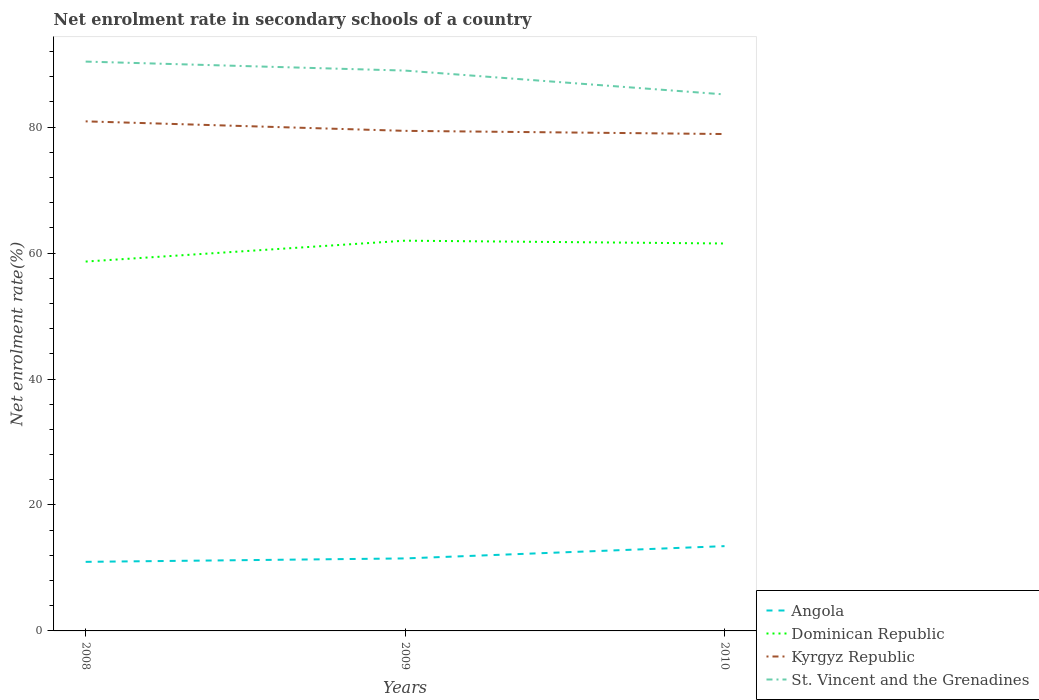How many different coloured lines are there?
Offer a terse response. 4. Does the line corresponding to Dominican Republic intersect with the line corresponding to Angola?
Your answer should be compact. No. Across all years, what is the maximum net enrolment rate in secondary schools in Angola?
Ensure brevity in your answer.  10.97. In which year was the net enrolment rate in secondary schools in Dominican Republic maximum?
Ensure brevity in your answer.  2008. What is the total net enrolment rate in secondary schools in Dominican Republic in the graph?
Your response must be concise. 0.45. What is the difference between the highest and the second highest net enrolment rate in secondary schools in St. Vincent and the Grenadines?
Ensure brevity in your answer.  5.21. What is the difference between the highest and the lowest net enrolment rate in secondary schools in Dominican Republic?
Your answer should be compact. 2. Is the net enrolment rate in secondary schools in Angola strictly greater than the net enrolment rate in secondary schools in St. Vincent and the Grenadines over the years?
Ensure brevity in your answer.  Yes. How many lines are there?
Your answer should be compact. 4. How many years are there in the graph?
Ensure brevity in your answer.  3. What is the difference between two consecutive major ticks on the Y-axis?
Offer a terse response. 20. Are the values on the major ticks of Y-axis written in scientific E-notation?
Your response must be concise. No. Does the graph contain any zero values?
Provide a succinct answer. No. Where does the legend appear in the graph?
Ensure brevity in your answer.  Bottom right. How many legend labels are there?
Provide a succinct answer. 4. How are the legend labels stacked?
Ensure brevity in your answer.  Vertical. What is the title of the graph?
Offer a terse response. Net enrolment rate in secondary schools of a country. What is the label or title of the Y-axis?
Provide a short and direct response. Net enrolment rate(%). What is the Net enrolment rate(%) in Angola in 2008?
Your response must be concise. 10.97. What is the Net enrolment rate(%) of Dominican Republic in 2008?
Offer a terse response. 58.66. What is the Net enrolment rate(%) in Kyrgyz Republic in 2008?
Keep it short and to the point. 80.92. What is the Net enrolment rate(%) of St. Vincent and the Grenadines in 2008?
Your answer should be very brief. 90.41. What is the Net enrolment rate(%) in Angola in 2009?
Your answer should be very brief. 11.51. What is the Net enrolment rate(%) in Dominican Republic in 2009?
Provide a succinct answer. 61.97. What is the Net enrolment rate(%) in Kyrgyz Republic in 2009?
Make the answer very short. 79.41. What is the Net enrolment rate(%) of St. Vincent and the Grenadines in 2009?
Your answer should be compact. 88.98. What is the Net enrolment rate(%) in Angola in 2010?
Offer a terse response. 13.46. What is the Net enrolment rate(%) in Dominican Republic in 2010?
Your response must be concise. 61.52. What is the Net enrolment rate(%) in Kyrgyz Republic in 2010?
Your response must be concise. 78.91. What is the Net enrolment rate(%) in St. Vincent and the Grenadines in 2010?
Your response must be concise. 85.2. Across all years, what is the maximum Net enrolment rate(%) of Angola?
Provide a short and direct response. 13.46. Across all years, what is the maximum Net enrolment rate(%) in Dominican Republic?
Give a very brief answer. 61.97. Across all years, what is the maximum Net enrolment rate(%) of Kyrgyz Republic?
Provide a succinct answer. 80.92. Across all years, what is the maximum Net enrolment rate(%) of St. Vincent and the Grenadines?
Your answer should be very brief. 90.41. Across all years, what is the minimum Net enrolment rate(%) in Angola?
Your answer should be very brief. 10.97. Across all years, what is the minimum Net enrolment rate(%) of Dominican Republic?
Keep it short and to the point. 58.66. Across all years, what is the minimum Net enrolment rate(%) in Kyrgyz Republic?
Make the answer very short. 78.91. Across all years, what is the minimum Net enrolment rate(%) of St. Vincent and the Grenadines?
Ensure brevity in your answer.  85.2. What is the total Net enrolment rate(%) in Angola in the graph?
Your answer should be very brief. 35.95. What is the total Net enrolment rate(%) in Dominican Republic in the graph?
Give a very brief answer. 182.15. What is the total Net enrolment rate(%) in Kyrgyz Republic in the graph?
Your answer should be compact. 239.24. What is the total Net enrolment rate(%) of St. Vincent and the Grenadines in the graph?
Offer a terse response. 264.59. What is the difference between the Net enrolment rate(%) in Angola in 2008 and that in 2009?
Make the answer very short. -0.54. What is the difference between the Net enrolment rate(%) in Dominican Republic in 2008 and that in 2009?
Offer a very short reply. -3.32. What is the difference between the Net enrolment rate(%) in Kyrgyz Republic in 2008 and that in 2009?
Provide a short and direct response. 1.51. What is the difference between the Net enrolment rate(%) in St. Vincent and the Grenadines in 2008 and that in 2009?
Your answer should be compact. 1.43. What is the difference between the Net enrolment rate(%) of Angola in 2008 and that in 2010?
Make the answer very short. -2.49. What is the difference between the Net enrolment rate(%) of Dominican Republic in 2008 and that in 2010?
Provide a short and direct response. -2.87. What is the difference between the Net enrolment rate(%) in Kyrgyz Republic in 2008 and that in 2010?
Make the answer very short. 2.01. What is the difference between the Net enrolment rate(%) of St. Vincent and the Grenadines in 2008 and that in 2010?
Your response must be concise. 5.21. What is the difference between the Net enrolment rate(%) of Angola in 2009 and that in 2010?
Give a very brief answer. -1.95. What is the difference between the Net enrolment rate(%) of Dominican Republic in 2009 and that in 2010?
Your answer should be very brief. 0.45. What is the difference between the Net enrolment rate(%) in Kyrgyz Republic in 2009 and that in 2010?
Your answer should be compact. 0.51. What is the difference between the Net enrolment rate(%) in St. Vincent and the Grenadines in 2009 and that in 2010?
Ensure brevity in your answer.  3.79. What is the difference between the Net enrolment rate(%) of Angola in 2008 and the Net enrolment rate(%) of Dominican Republic in 2009?
Offer a very short reply. -51. What is the difference between the Net enrolment rate(%) in Angola in 2008 and the Net enrolment rate(%) in Kyrgyz Republic in 2009?
Ensure brevity in your answer.  -68.44. What is the difference between the Net enrolment rate(%) of Angola in 2008 and the Net enrolment rate(%) of St. Vincent and the Grenadines in 2009?
Keep it short and to the point. -78.01. What is the difference between the Net enrolment rate(%) in Dominican Republic in 2008 and the Net enrolment rate(%) in Kyrgyz Republic in 2009?
Make the answer very short. -20.76. What is the difference between the Net enrolment rate(%) in Dominican Republic in 2008 and the Net enrolment rate(%) in St. Vincent and the Grenadines in 2009?
Provide a short and direct response. -30.33. What is the difference between the Net enrolment rate(%) of Kyrgyz Republic in 2008 and the Net enrolment rate(%) of St. Vincent and the Grenadines in 2009?
Offer a very short reply. -8.06. What is the difference between the Net enrolment rate(%) of Angola in 2008 and the Net enrolment rate(%) of Dominican Republic in 2010?
Ensure brevity in your answer.  -50.55. What is the difference between the Net enrolment rate(%) of Angola in 2008 and the Net enrolment rate(%) of Kyrgyz Republic in 2010?
Make the answer very short. -67.94. What is the difference between the Net enrolment rate(%) of Angola in 2008 and the Net enrolment rate(%) of St. Vincent and the Grenadines in 2010?
Give a very brief answer. -74.23. What is the difference between the Net enrolment rate(%) of Dominican Republic in 2008 and the Net enrolment rate(%) of Kyrgyz Republic in 2010?
Your answer should be very brief. -20.25. What is the difference between the Net enrolment rate(%) in Dominican Republic in 2008 and the Net enrolment rate(%) in St. Vincent and the Grenadines in 2010?
Make the answer very short. -26.54. What is the difference between the Net enrolment rate(%) in Kyrgyz Republic in 2008 and the Net enrolment rate(%) in St. Vincent and the Grenadines in 2010?
Offer a very short reply. -4.28. What is the difference between the Net enrolment rate(%) in Angola in 2009 and the Net enrolment rate(%) in Dominican Republic in 2010?
Your answer should be very brief. -50.01. What is the difference between the Net enrolment rate(%) in Angola in 2009 and the Net enrolment rate(%) in Kyrgyz Republic in 2010?
Provide a succinct answer. -67.39. What is the difference between the Net enrolment rate(%) of Angola in 2009 and the Net enrolment rate(%) of St. Vincent and the Grenadines in 2010?
Provide a succinct answer. -73.68. What is the difference between the Net enrolment rate(%) in Dominican Republic in 2009 and the Net enrolment rate(%) in Kyrgyz Republic in 2010?
Give a very brief answer. -16.93. What is the difference between the Net enrolment rate(%) in Dominican Republic in 2009 and the Net enrolment rate(%) in St. Vincent and the Grenadines in 2010?
Keep it short and to the point. -23.22. What is the difference between the Net enrolment rate(%) of Kyrgyz Republic in 2009 and the Net enrolment rate(%) of St. Vincent and the Grenadines in 2010?
Provide a succinct answer. -5.78. What is the average Net enrolment rate(%) of Angola per year?
Offer a terse response. 11.98. What is the average Net enrolment rate(%) in Dominican Republic per year?
Ensure brevity in your answer.  60.72. What is the average Net enrolment rate(%) of Kyrgyz Republic per year?
Offer a terse response. 79.75. What is the average Net enrolment rate(%) of St. Vincent and the Grenadines per year?
Ensure brevity in your answer.  88.2. In the year 2008, what is the difference between the Net enrolment rate(%) in Angola and Net enrolment rate(%) in Dominican Republic?
Your response must be concise. -47.69. In the year 2008, what is the difference between the Net enrolment rate(%) in Angola and Net enrolment rate(%) in Kyrgyz Republic?
Your answer should be very brief. -69.95. In the year 2008, what is the difference between the Net enrolment rate(%) of Angola and Net enrolment rate(%) of St. Vincent and the Grenadines?
Provide a succinct answer. -79.44. In the year 2008, what is the difference between the Net enrolment rate(%) in Dominican Republic and Net enrolment rate(%) in Kyrgyz Republic?
Provide a short and direct response. -22.26. In the year 2008, what is the difference between the Net enrolment rate(%) of Dominican Republic and Net enrolment rate(%) of St. Vincent and the Grenadines?
Offer a terse response. -31.75. In the year 2008, what is the difference between the Net enrolment rate(%) of Kyrgyz Republic and Net enrolment rate(%) of St. Vincent and the Grenadines?
Your answer should be compact. -9.49. In the year 2009, what is the difference between the Net enrolment rate(%) in Angola and Net enrolment rate(%) in Dominican Republic?
Offer a very short reply. -50.46. In the year 2009, what is the difference between the Net enrolment rate(%) in Angola and Net enrolment rate(%) in Kyrgyz Republic?
Keep it short and to the point. -67.9. In the year 2009, what is the difference between the Net enrolment rate(%) in Angola and Net enrolment rate(%) in St. Vincent and the Grenadines?
Provide a succinct answer. -77.47. In the year 2009, what is the difference between the Net enrolment rate(%) of Dominican Republic and Net enrolment rate(%) of Kyrgyz Republic?
Offer a terse response. -17.44. In the year 2009, what is the difference between the Net enrolment rate(%) of Dominican Republic and Net enrolment rate(%) of St. Vincent and the Grenadines?
Provide a short and direct response. -27.01. In the year 2009, what is the difference between the Net enrolment rate(%) of Kyrgyz Republic and Net enrolment rate(%) of St. Vincent and the Grenadines?
Provide a succinct answer. -9.57. In the year 2010, what is the difference between the Net enrolment rate(%) in Angola and Net enrolment rate(%) in Dominican Republic?
Make the answer very short. -48.06. In the year 2010, what is the difference between the Net enrolment rate(%) in Angola and Net enrolment rate(%) in Kyrgyz Republic?
Give a very brief answer. -65.44. In the year 2010, what is the difference between the Net enrolment rate(%) of Angola and Net enrolment rate(%) of St. Vincent and the Grenadines?
Your answer should be compact. -71.73. In the year 2010, what is the difference between the Net enrolment rate(%) of Dominican Republic and Net enrolment rate(%) of Kyrgyz Republic?
Ensure brevity in your answer.  -17.38. In the year 2010, what is the difference between the Net enrolment rate(%) of Dominican Republic and Net enrolment rate(%) of St. Vincent and the Grenadines?
Ensure brevity in your answer.  -23.67. In the year 2010, what is the difference between the Net enrolment rate(%) in Kyrgyz Republic and Net enrolment rate(%) in St. Vincent and the Grenadines?
Your answer should be compact. -6.29. What is the ratio of the Net enrolment rate(%) of Angola in 2008 to that in 2009?
Your response must be concise. 0.95. What is the ratio of the Net enrolment rate(%) of Dominican Republic in 2008 to that in 2009?
Give a very brief answer. 0.95. What is the ratio of the Net enrolment rate(%) in Kyrgyz Republic in 2008 to that in 2009?
Your answer should be very brief. 1.02. What is the ratio of the Net enrolment rate(%) of St. Vincent and the Grenadines in 2008 to that in 2009?
Provide a succinct answer. 1.02. What is the ratio of the Net enrolment rate(%) in Angola in 2008 to that in 2010?
Give a very brief answer. 0.81. What is the ratio of the Net enrolment rate(%) of Dominican Republic in 2008 to that in 2010?
Your answer should be very brief. 0.95. What is the ratio of the Net enrolment rate(%) in Kyrgyz Republic in 2008 to that in 2010?
Your response must be concise. 1.03. What is the ratio of the Net enrolment rate(%) of St. Vincent and the Grenadines in 2008 to that in 2010?
Provide a short and direct response. 1.06. What is the ratio of the Net enrolment rate(%) of Angola in 2009 to that in 2010?
Your answer should be compact. 0.86. What is the ratio of the Net enrolment rate(%) of Dominican Republic in 2009 to that in 2010?
Your response must be concise. 1.01. What is the ratio of the Net enrolment rate(%) of Kyrgyz Republic in 2009 to that in 2010?
Give a very brief answer. 1.01. What is the ratio of the Net enrolment rate(%) in St. Vincent and the Grenadines in 2009 to that in 2010?
Keep it short and to the point. 1.04. What is the difference between the highest and the second highest Net enrolment rate(%) in Angola?
Keep it short and to the point. 1.95. What is the difference between the highest and the second highest Net enrolment rate(%) of Dominican Republic?
Offer a very short reply. 0.45. What is the difference between the highest and the second highest Net enrolment rate(%) of Kyrgyz Republic?
Offer a very short reply. 1.51. What is the difference between the highest and the second highest Net enrolment rate(%) in St. Vincent and the Grenadines?
Offer a terse response. 1.43. What is the difference between the highest and the lowest Net enrolment rate(%) in Angola?
Offer a very short reply. 2.49. What is the difference between the highest and the lowest Net enrolment rate(%) of Dominican Republic?
Your response must be concise. 3.32. What is the difference between the highest and the lowest Net enrolment rate(%) in Kyrgyz Republic?
Provide a succinct answer. 2.01. What is the difference between the highest and the lowest Net enrolment rate(%) of St. Vincent and the Grenadines?
Your response must be concise. 5.21. 